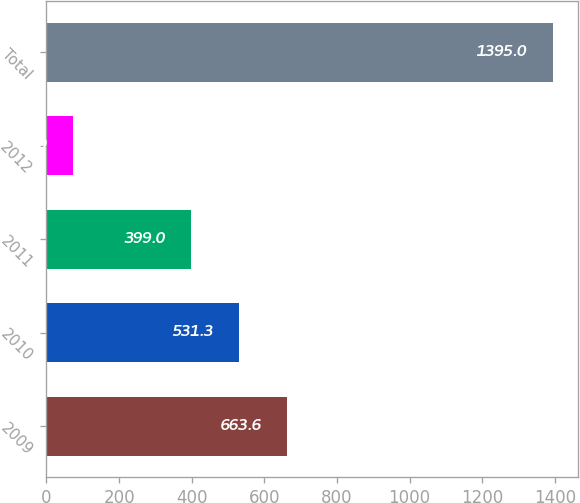Convert chart. <chart><loc_0><loc_0><loc_500><loc_500><bar_chart><fcel>2009<fcel>2010<fcel>2011<fcel>2012<fcel>Total<nl><fcel>663.6<fcel>531.3<fcel>399<fcel>72<fcel>1395<nl></chart> 